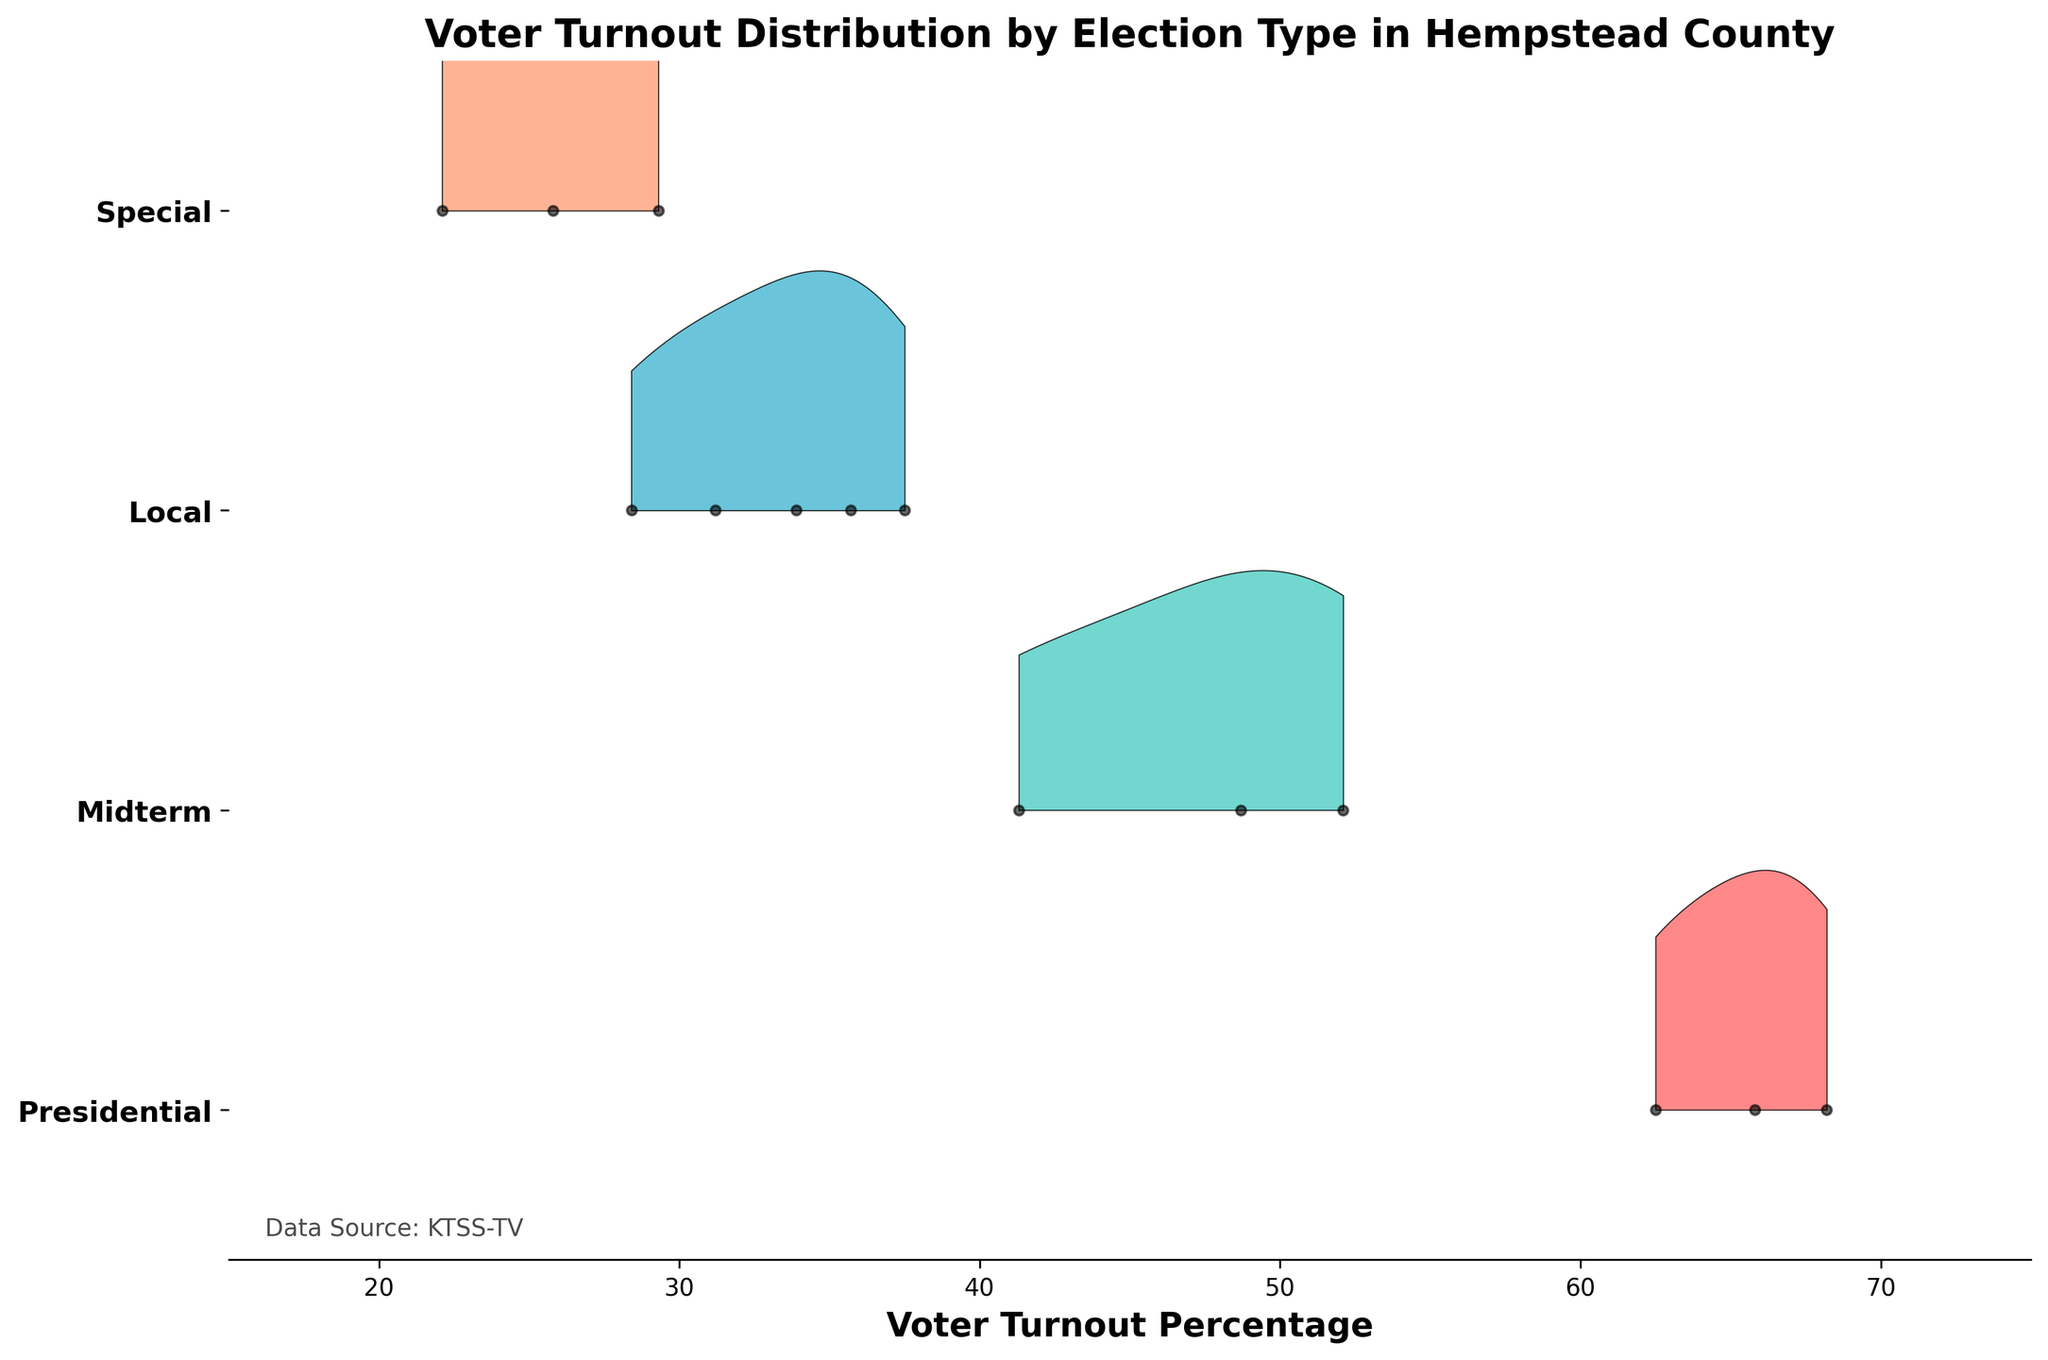what is the title of the figure? The title of the figure is generally located at the top of the plot area and is used to describe the content or purpose of the figure.
Answer: Voter Turnout Distribution by Election Type in Hempstead County Which election type has the highest voter turnout percentage? To determine which election type has the highest voter turnout percentage, we look at the farthest point to the right along the x-axis within each election type's distribution. The highest value lies within the Presidential elections range.
Answer: Presidential Which color represents the Midterm elections? Each election type in the Ridgeline plot is represented by a distinct color. By looking at the y-axis label for Midterm elections, we observe the ridge filled with that specified color.
Answer: Green How many local election years are displayed in the plot? For the number of years shown for local elections, count each dot in the data series corresponding to Local elections on the y-axis. Local elections have dots for these years: 2013, 2015, 2017, 2019, and 2021. There are five years displayed.
Answer: 5 Are the voter turnout percentages generally lower for Special or Local elections? Compare the ridgeline distributions for Special and Local elections. Look for the overall shift in voter turnout percentages. The distribution for Special elections lies mostly to the left of the Local elections, indicating lower percentages.
Answer: Special What is the average voter turnout percentage for Midterm elections between 2014 and 2022? Calculate the average by summing up the voter turnout percentages for Midterm elections (41.3, 48.7, 52.1) and dividing by the number of data points. (41.3 + 48.7 + 52.1) / 3 = 142.1 / 3 = 47.37
Answer: 47.37 Which election type shows the most consistent voter turnout over the years? Consistency can be evaluated by looking at the width and spread of the distribution peaks. The narrower and more centered the distribution, the more consistent the voter turnout. Local elections seem to have a relatively narrow and centered distribution compared to others.
Answer: Local How did voter turnout change for Presidential elections from 2012 to 2020? Check the voter turnout percentages for Presidential elections in 2012 (62.5), 2016 (65.8), and 2020 (68.2). Notice the gradual increase across these years.
Answer: Increased What is the range of voter turnout percentages for Special elections? Determine the minimum and maximum voter turnout values for Special elections by observing where the distribution extends on the x-axis. The range is from approximately 22.1% to 29.3%.
Answer: 22.1% to 29.3% Is the voter turnout percentage for Local elections higher or lower than for Midterm elections? Compare the ridgeline distributions for Local and Midterm elections. Refer to specific data points as well, such as the max voter turnout percentages within each category. Midterm election turnout percentages are generally higher.
Answer: Lower 